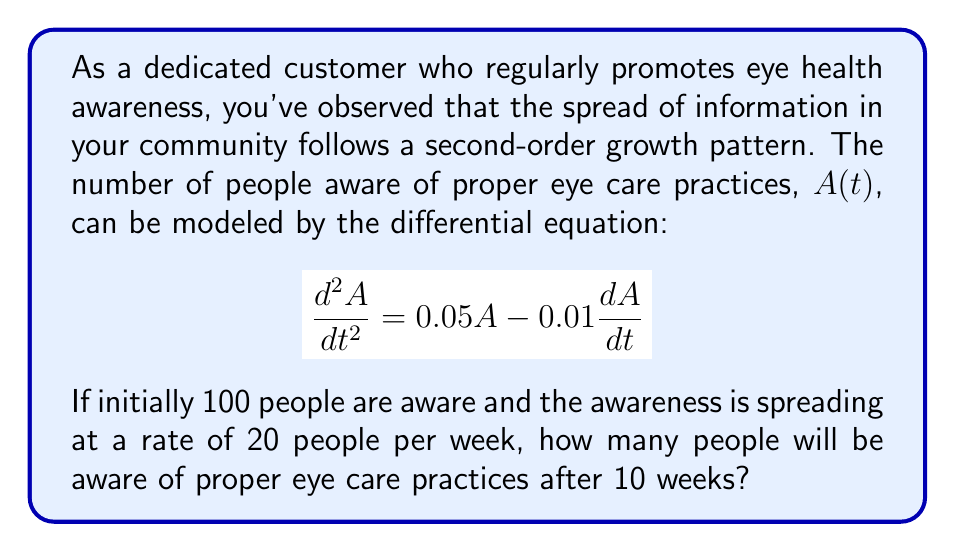Help me with this question. To solve this problem, we need to follow these steps:

1) First, we identify the initial conditions:
   $A(0) = 100$ (initial number of aware people)
   $A'(0) = 20$ (initial rate of awareness spread)

2) The general solution for this second-order linear differential equation is:
   $A(t) = C_1e^{r_1t} + C_2e^{r_2t}$

3) To find $r_1$ and $r_2$, we solve the characteristic equation:
   $r^2 + 0.01r - 0.05 = 0$
   Using the quadratic formula, we get:
   $r_1 = 0.2207$ and $r_2 = -0.2307$

4) So, our general solution is:
   $A(t) = C_1e^{0.2207t} + C_2e^{-0.2307t}$

5) To find $C_1$ and $C_2$, we use the initial conditions:
   $A(0) = C_1 + C_2 = 100$
   $A'(0) = 0.2207C_1 - 0.2307C_2 = 20$

6) Solving these equations:
   $C_1 = 61.8326$ and $C_2 = 38.1674$

7) Our particular solution is:
   $A(t) = 61.8326e^{0.2207t} + 38.1674e^{-0.2307t}$

8) To find $A(10)$, we substitute $t = 10$:
   $A(10) = 61.8326e^{2.207} + 38.1674e^{-2.307}$
   $= 574.0388 + 3.8249$
   $= 577.8637$

9) Rounding to the nearest whole number (as we're counting people):
   $A(10) \approx 578$
Answer: 578 people 